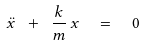Convert formula to latex. <formula><loc_0><loc_0><loc_500><loc_500>\ddot { x } \ + \ \frac { k } { m } \, x \ \ = \ \ 0</formula> 